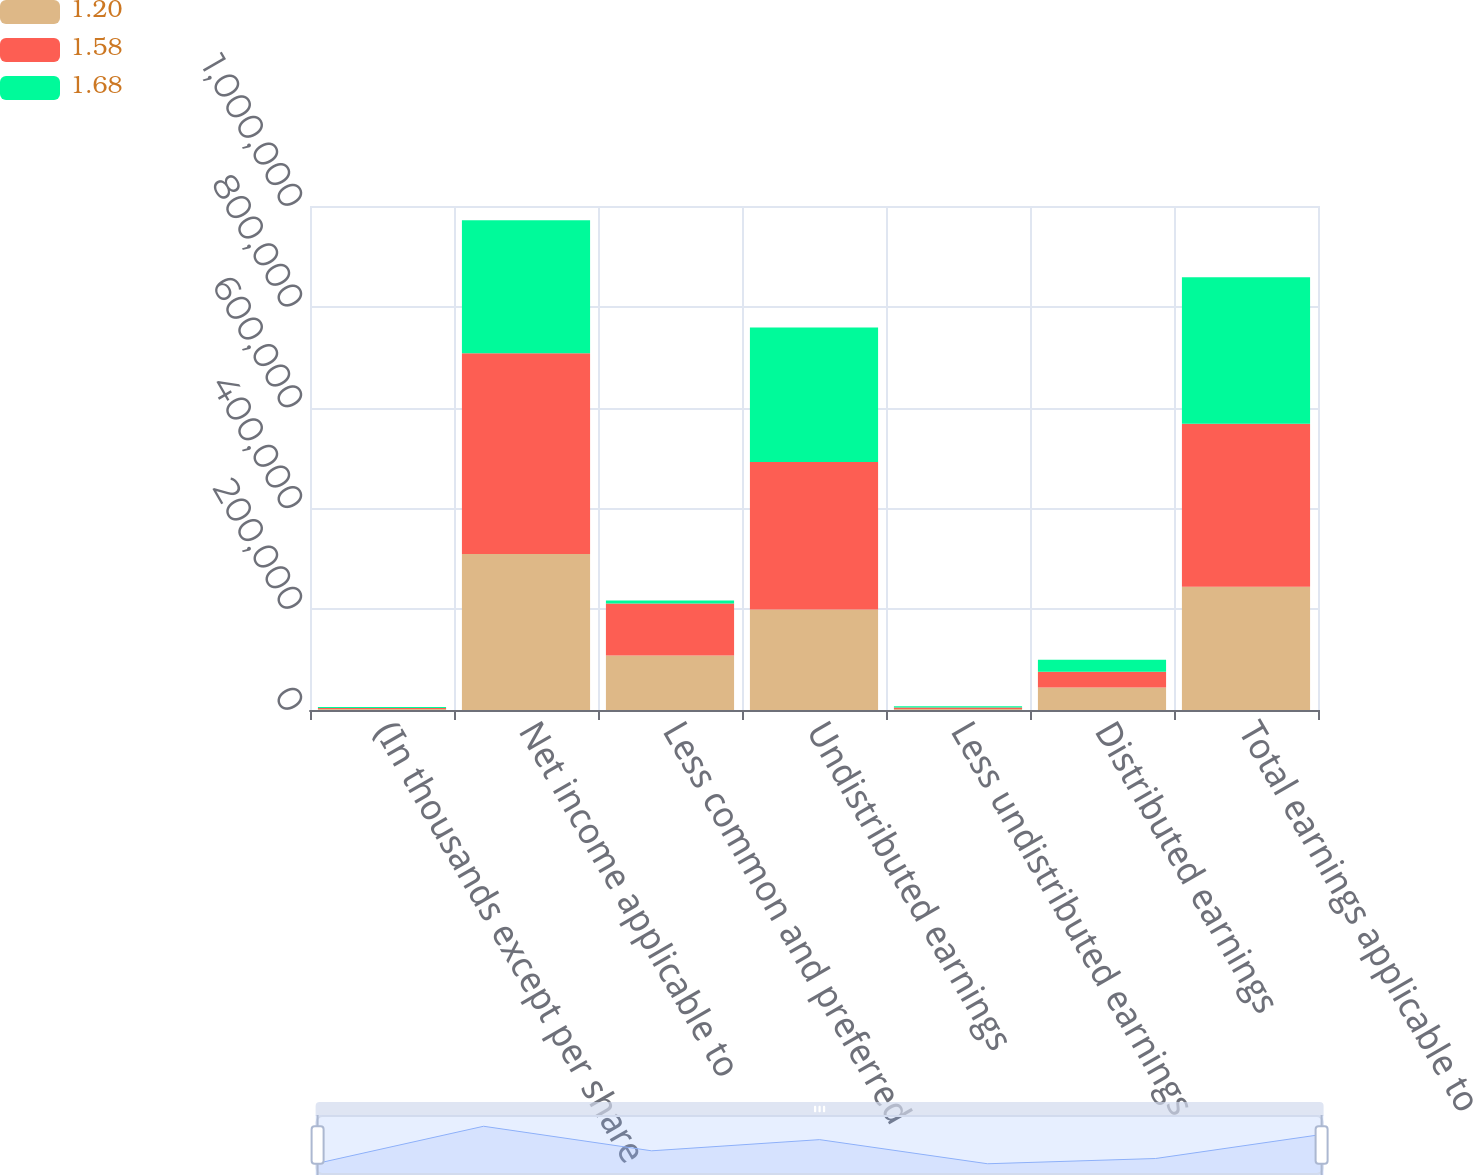<chart> <loc_0><loc_0><loc_500><loc_500><stacked_bar_chart><ecel><fcel>(In thousands except per share<fcel>Net income applicable to<fcel>Less common and preferred<fcel>Undistributed earnings<fcel>Less undistributed earnings<fcel>Distributed earnings<fcel>Total earnings applicable to<nl><fcel>1.2<fcel>2015<fcel>309471<fcel>107990<fcel>199645<fcel>1836<fcel>44816<fcel>244461<nl><fcel>1.58<fcel>2014<fcel>398462<fcel>103111<fcel>292418<fcel>2933<fcel>30983<fcel>323401<nl><fcel>1.68<fcel>2013<fcel>263791<fcel>6094<fcel>267053<fcel>2832<fcel>23916<fcel>290969<nl></chart> 